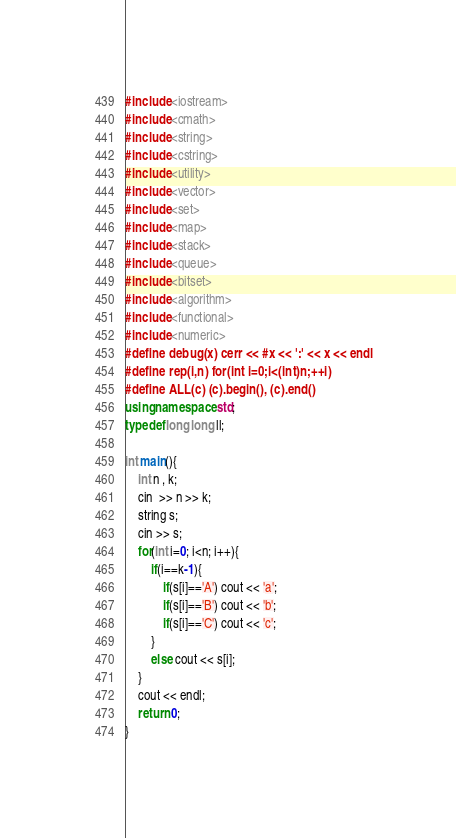Convert code to text. <code><loc_0><loc_0><loc_500><loc_500><_C++_>#include <iostream>
#include <cmath>
#include <string>
#include <cstring>
#include <utility>
#include <vector>
#include <set>
#include <map>
#include <stack>
#include <queue>
#include <bitset>
#include <algorithm>
#include <functional>
#include <numeric>
#define debug(x) cerr << #x << ':' << x << endl
#define rep(i,n) for(int i=0;i<(int)n;++i)
#define ALL(c) (c).begin(), (c).end()
using namespace std;
typedef long long ll;

int main(){
    int n , k;
    cin  >> n >> k;
    string s;
    cin >> s;
    for(int i=0; i<n; i++){
        if(i==k-1){
            if(s[i]=='A') cout << 'a';
            if(s[i]=='B') cout << 'b';
            if(s[i]=='C') cout << 'c';
        }
        else cout << s[i];
    }
    cout << endl;
    return 0;
}</code> 